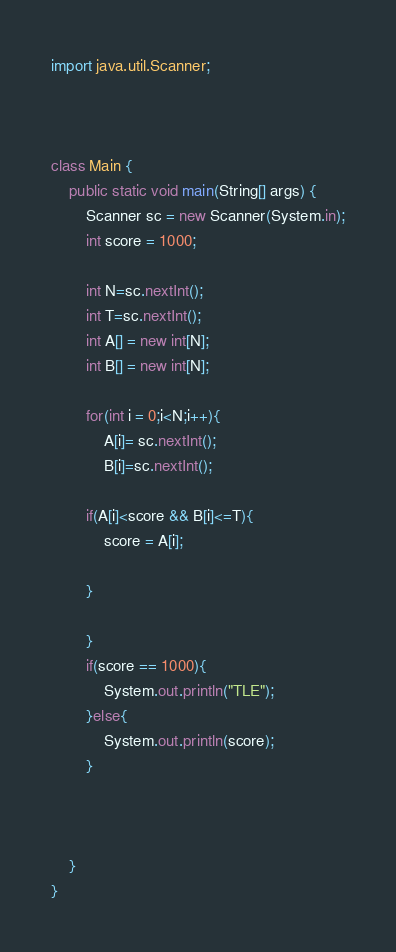Convert code to text. <code><loc_0><loc_0><loc_500><loc_500><_Java_>import java.util.Scanner;



class Main {
    public static void main(String[] args) {
    	Scanner sc = new Scanner(System.in);
    	int score = 1000;

    	int N=sc.nextInt();
    	int T=sc.nextInt();
    	int A[] = new int[N];
		int B[] = new int[N];

    	for(int i = 0;i<N;i++){
    		A[i]= sc.nextInt();
    		B[i]=sc.nextInt();

    	if(A[i]<score && B[i]<=T){
    		score = A[i];

    	}

    	}
    	if(score == 1000){
    		System.out.println("TLE");
    	}else{
    		System.out.println(score);
    	}



    }
}</code> 